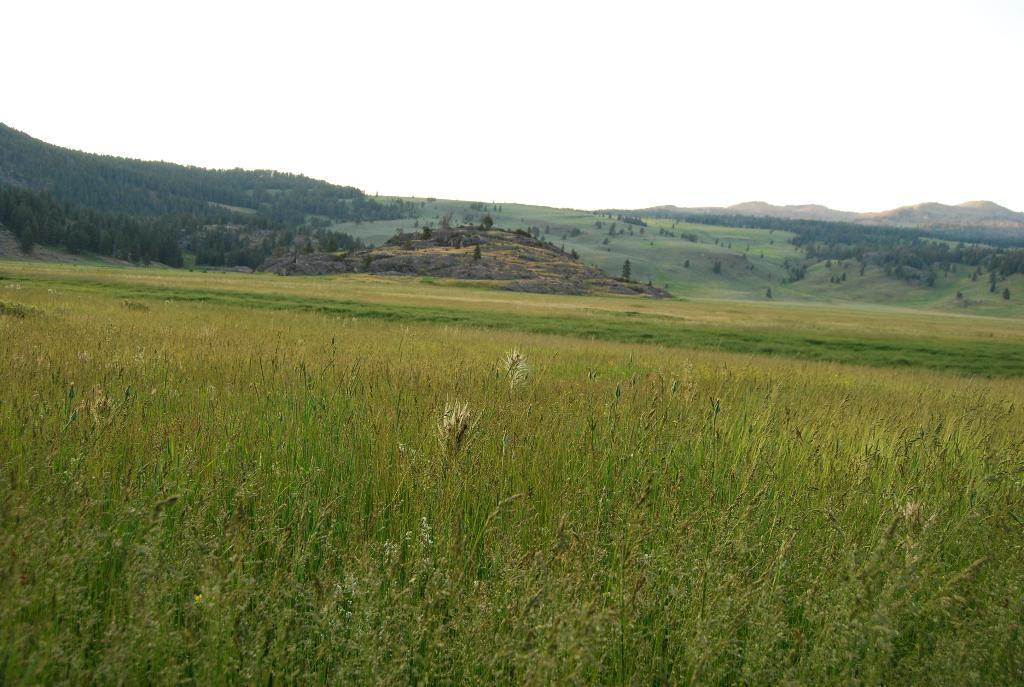What type of vegetation can be seen in the image? There is grass and trees in the image. What else is present on the ground in the image? There are other objects on the ground in the image. What can be seen in the distance in the image? There are mountains visible in the background of the image. What is visible above the mountains in the image? The sky is visible in the background of the image. What type of engine is powering the plot in the image? There is no engine or plot present in the image; it features natural elements such as grass, trees, mountains, and the sky. 